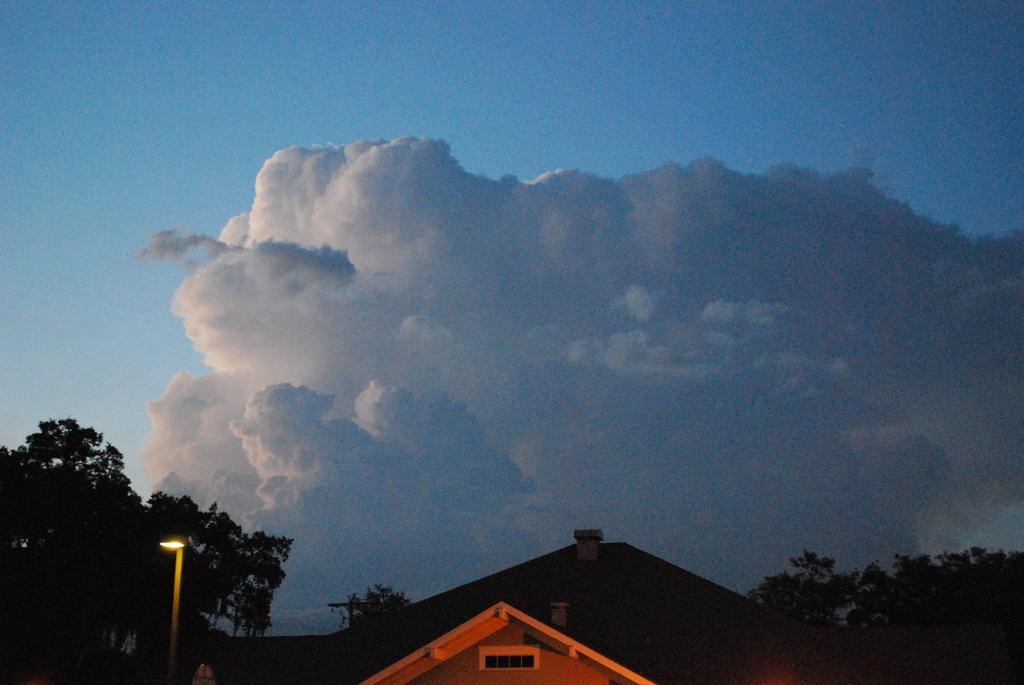What is the main structure visible in the picture? The main structure visible in the picture is the roof of a house. What is located beside the house? There is a pole with a light beside the house. What type of vegetation can be seen in the picture? There are trees in the picture. What is visible in the sky in the picture? There are clouds present in the sky. What invention is being demonstrated by the clouds in the picture? There is no invention being demonstrated by the clouds in the picture; they are simply visible in the sky. 